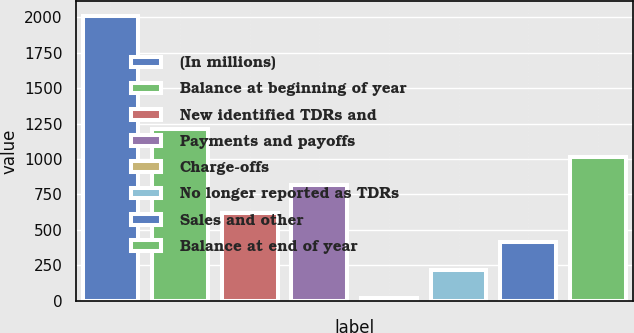Convert chart to OTSL. <chart><loc_0><loc_0><loc_500><loc_500><bar_chart><fcel>(In millions)<fcel>Balance at beginning of year<fcel>New identified TDRs and<fcel>Payments and payoffs<fcel>Charge-offs<fcel>No longer reported as TDRs<fcel>Sales and other<fcel>Balance at end of year<nl><fcel>2013<fcel>1215<fcel>616.5<fcel>816<fcel>18<fcel>217.5<fcel>417<fcel>1015.5<nl></chart> 